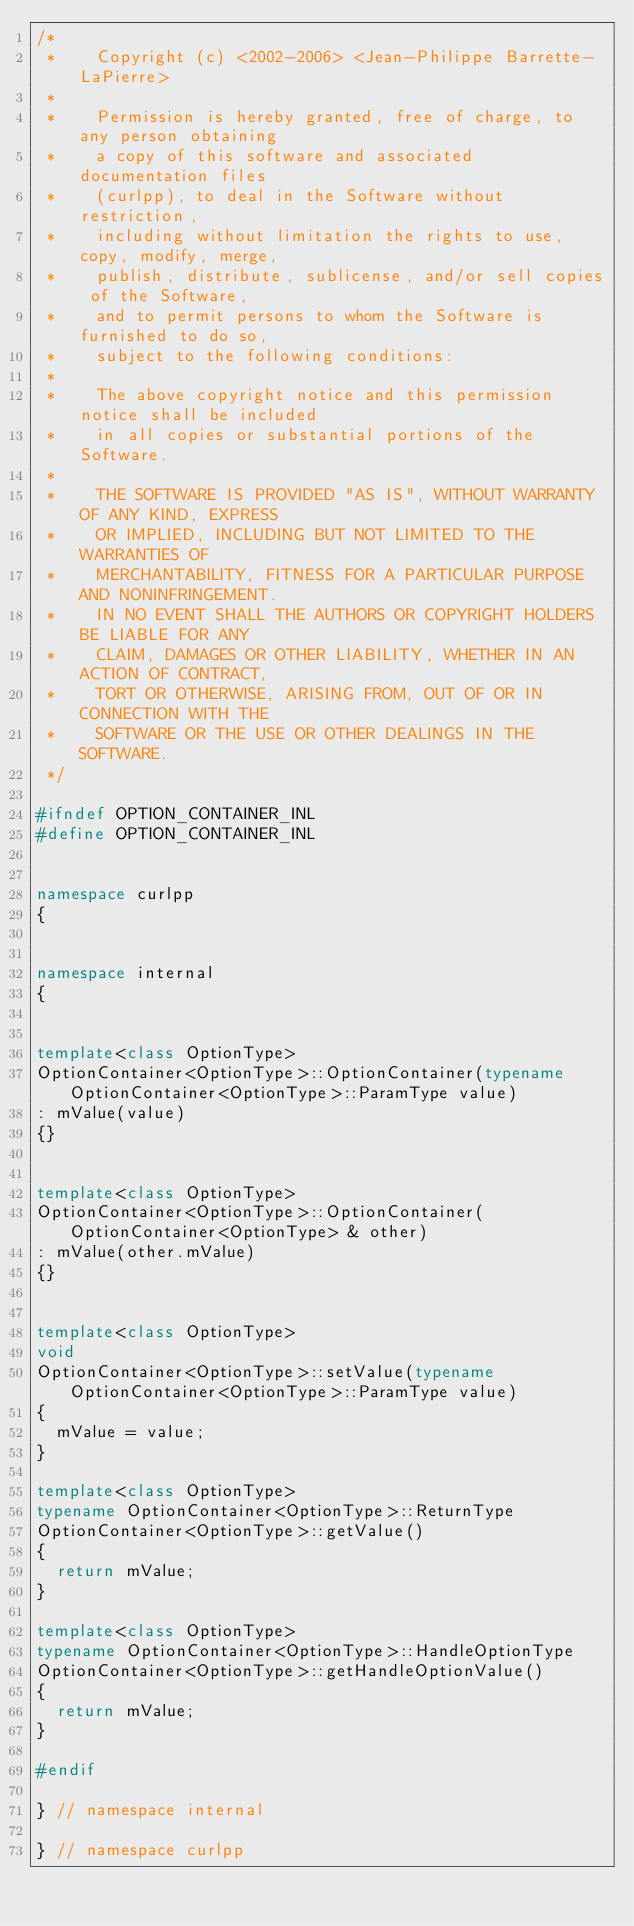Convert code to text. <code><loc_0><loc_0><loc_500><loc_500><_C++_>/*
 *    Copyright (c) <2002-2006> <Jean-Philippe Barrette-LaPierre>
 *    
 *    Permission is hereby granted, free of charge, to any person obtaining
 *    a copy of this software and associated documentation files 
 *    (curlpp), to deal in the Software without restriction, 
 *    including without limitation the rights to use, copy, modify, merge,
 *    publish, distribute, sublicense, and/or sell copies of the Software,
 *    and to permit persons to whom the Software is furnished to do so, 
 *    subject to the following conditions:
 *    
 *    The above copyright notice and this permission notice shall be included
 *    in all copies or substantial portions of the Software.
 *    
 *    THE SOFTWARE IS PROVIDED "AS IS", WITHOUT WARRANTY OF ANY KIND, EXPRESS
 *    OR IMPLIED, INCLUDING BUT NOT LIMITED TO THE WARRANTIES OF
 *    MERCHANTABILITY, FITNESS FOR A PARTICULAR PURPOSE AND NONINFRINGEMENT. 
 *    IN NO EVENT SHALL THE AUTHORS OR COPYRIGHT HOLDERS BE LIABLE FOR ANY 
 *    CLAIM, DAMAGES OR OTHER LIABILITY, WHETHER IN AN ACTION OF CONTRACT, 
 *    TORT OR OTHERWISE, ARISING FROM, OUT OF OR IN CONNECTION WITH THE
 *    SOFTWARE OR THE USE OR OTHER DEALINGS IN THE SOFTWARE.
 */

#ifndef OPTION_CONTAINER_INL
#define OPTION_CONTAINER_INL


namespace curlpp
{


namespace internal
{


template<class OptionType>
OptionContainer<OptionType>::OptionContainer(typename OptionContainer<OptionType>::ParamType value)
: mValue(value)
{}


template<class OptionType>
OptionContainer<OptionType>::OptionContainer(OptionContainer<OptionType> & other) 
: mValue(other.mValue)
{}


template<class OptionType>
void
OptionContainer<OptionType>::setValue(typename OptionContainer<OptionType>::ParamType value)
{
  mValue = value;
}

template<class OptionType>
typename OptionContainer<OptionType>::ReturnType
OptionContainer<OptionType>::getValue()
{
  return mValue;
}

template<class OptionType>
typename OptionContainer<OptionType>::HandleOptionType
OptionContainer<OptionType>::getHandleOptionValue()
{
  return mValue;
}

#endif

} // namespace internal

} // namespace curlpp
</code> 